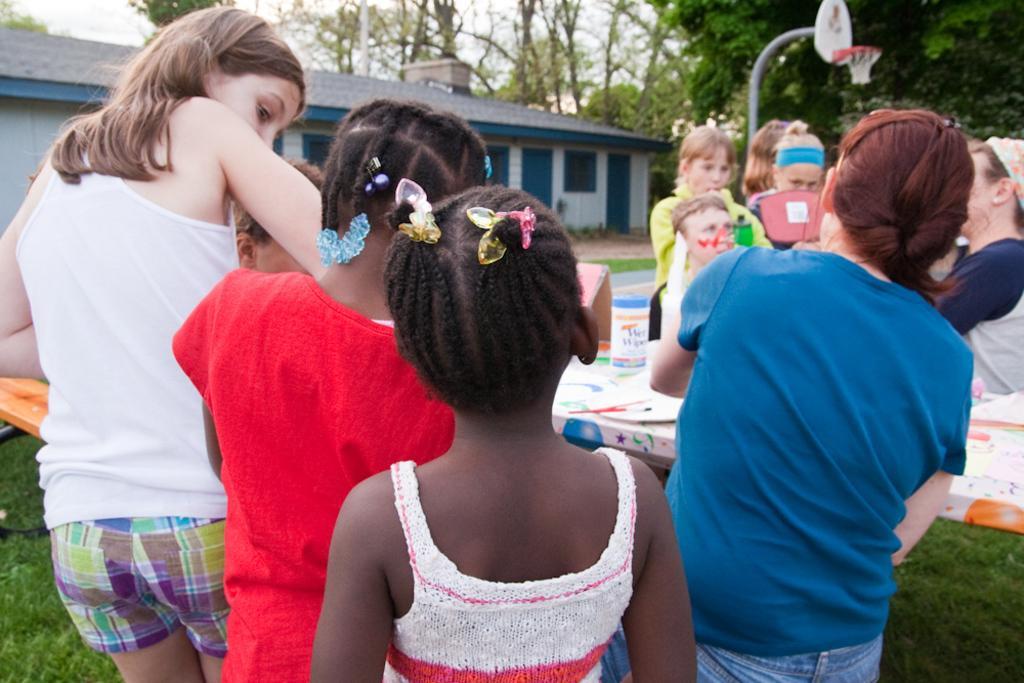Describe this image in one or two sentences. In this image, there are a few people. We can see a table with some objects. We can also see the ground covered with grass. There are a few trees. We can see a house and the sky. We can also see an object on the left. 